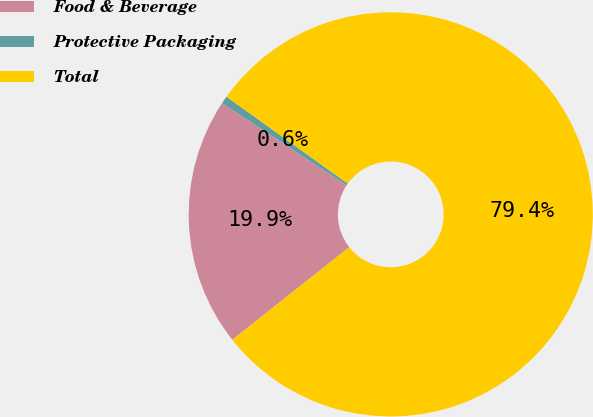<chart> <loc_0><loc_0><loc_500><loc_500><pie_chart><fcel>Food & Beverage<fcel>Protective Packaging<fcel>Total<nl><fcel>19.94%<fcel>0.61%<fcel>79.45%<nl></chart> 